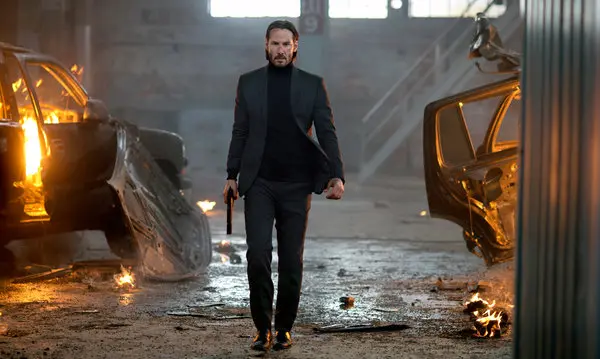What would be a realistic objective for the character in this scene? In a realistic scenario, the character is likely on a critical mission to rescue a hostage or retrieve vital information that could turn the tide against a dangerous crime syndicate. The burning cars are the aftermath of a fierce battle or chase, and he is now making his way through the wreckage to reach his objective. His determined expression and firm grip on the gun indicate that failure is not an option, and he is prepared to face any remaining threats head-on. In a few words, sum up the character's predicament. Navigating chaos to fulfill a crucial, high-risk mission. 